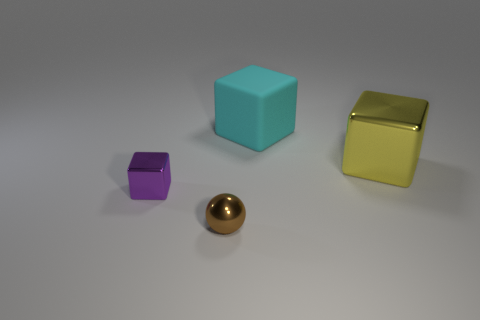How many cylinders are brown objects or tiny purple things?
Provide a short and direct response. 0. There is a cube in front of the big yellow object; are there any shiny objects in front of it?
Give a very brief answer. Yes. Is there anything else that has the same material as the large cyan object?
Your answer should be compact. No. There is a tiny brown thing; is its shape the same as the object that is right of the matte object?
Your answer should be very brief. No. How many other objects are there of the same size as the cyan rubber block?
Your answer should be compact. 1. How many blue things are either large rubber cubes or small balls?
Your answer should be very brief. 0. What number of things are both on the right side of the brown object and to the left of the big metal cube?
Provide a short and direct response. 1. The big cube that is on the left side of the metallic cube that is behind the small object left of the tiny brown sphere is made of what material?
Provide a short and direct response. Rubber. How many blocks are made of the same material as the tiny brown ball?
Ensure brevity in your answer.  2. There is a purple thing that is the same size as the brown metal thing; what shape is it?
Keep it short and to the point. Cube. 